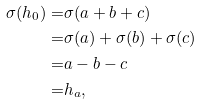<formula> <loc_0><loc_0><loc_500><loc_500>\sigma ( h _ { 0 } ) = & \sigma ( a + b + c ) \\ = & \sigma ( a ) + \sigma ( b ) + \sigma ( c ) \\ = & a - b - c \\ = & h _ { a } ,</formula> 